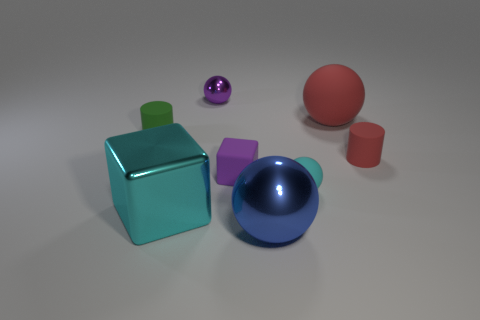Add 2 green rubber things. How many objects exist? 10 Subtract all blocks. How many objects are left? 6 Subtract 0 purple cylinders. How many objects are left? 8 Subtract all cyan rubber things. Subtract all tiny cyan objects. How many objects are left? 6 Add 7 tiny shiny spheres. How many tiny shiny spheres are left? 8 Add 3 red things. How many red things exist? 5 